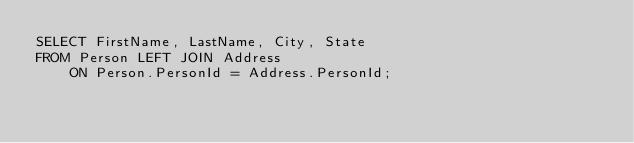Convert code to text. <code><loc_0><loc_0><loc_500><loc_500><_SQL_>SELECT FirstName, LastName, City, State
FROM Person LEFT JOIN Address
    ON Person.PersonId = Address.PersonId;
</code> 